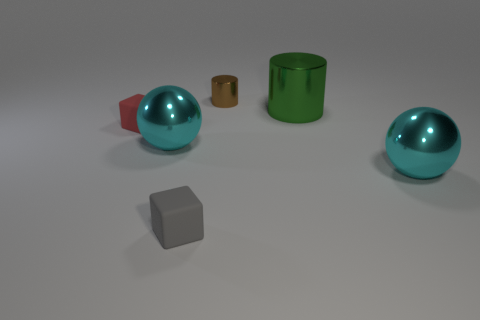Are there any big cyan objects on the left side of the brown shiny thing?
Offer a terse response. Yes. What number of tiny objects have the same shape as the big green metal thing?
Your answer should be compact. 1. What color is the small matte cube that is left of the large cyan object that is behind the cyan thing to the right of the big green thing?
Give a very brief answer. Red. Is the cyan sphere that is right of the brown metal cylinder made of the same material as the big cyan sphere that is on the left side of the brown cylinder?
Provide a succinct answer. Yes. How many things are tiny rubber blocks that are behind the small gray thing or large cyan objects?
Your response must be concise. 3. How many objects are tiny gray rubber blocks or big shiny objects in front of the red matte block?
Provide a short and direct response. 3. What number of other blocks are the same size as the red cube?
Make the answer very short. 1. Is the number of small brown shiny cylinders on the right side of the big cylinder less than the number of big objects in front of the small gray cube?
Offer a very short reply. No. What number of shiny objects are small gray cubes or small brown cylinders?
Your response must be concise. 1. The big green thing has what shape?
Offer a terse response. Cylinder. 